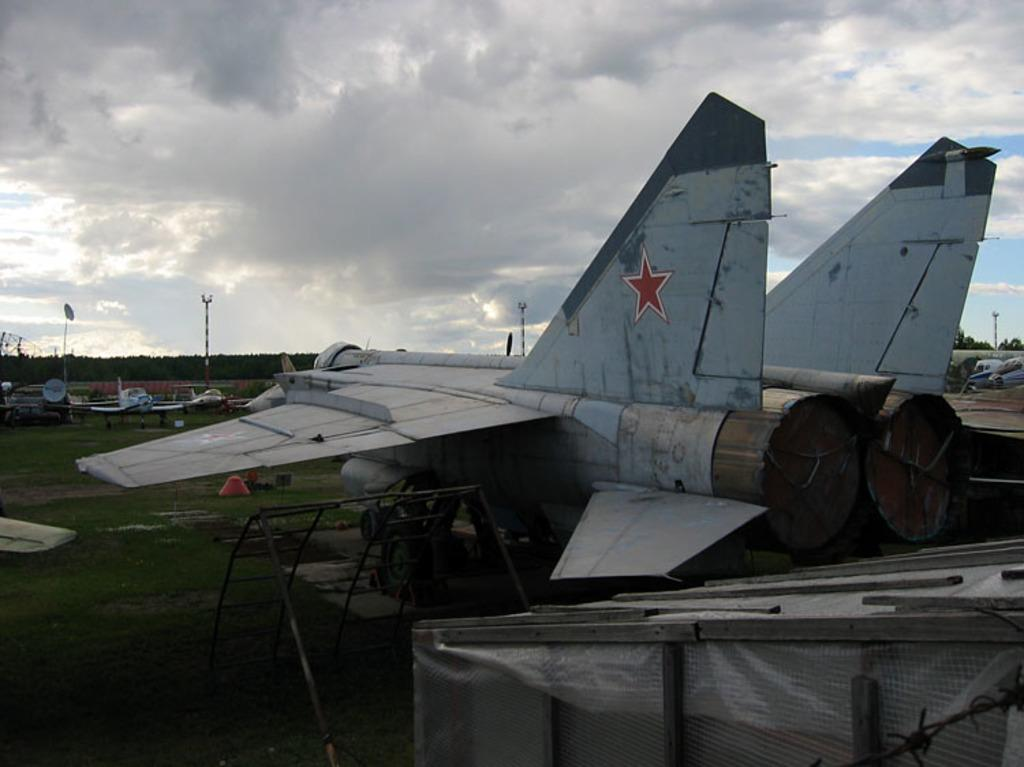What is the main subject of the image? The main subject of the image is flights. What can be seen near the flights? There are ladders near the flights. What type of terrain is visible in the image? There is grass on the ground. What can be seen in the background of the image? The sky with clouds and trees are visible in the background. What type of throat apparatus can be seen in the image? There is no throat apparatus present in the image. Can you describe the table in the image? There is no table present in the image. 